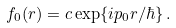Convert formula to latex. <formula><loc_0><loc_0><loc_500><loc_500>f _ { 0 } ( r ) = c \exp \{ i p _ { 0 } r / \hbar { \} } \, .</formula> 